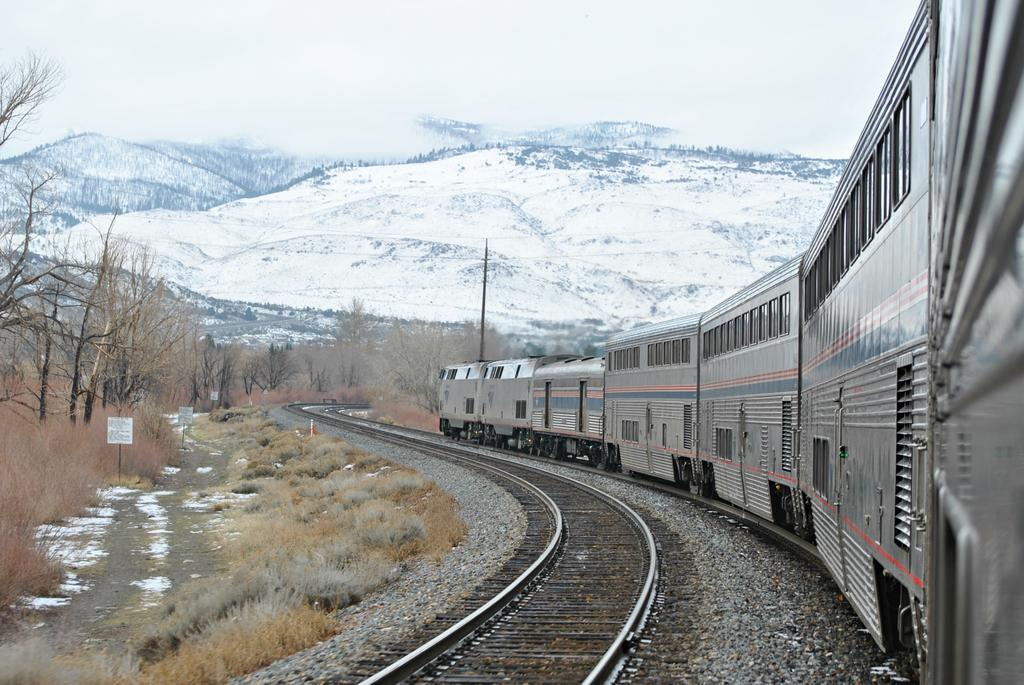What is the main subject of the image? The main subject of the image is a locomotive on the track. What is the condition of the track next to the locomotive? The track next to the locomotive is empty. What type of natural elements can be seen in the image? Stones, shrubs, trees, and mountains are visible in the image. What man-made structures are present in the image? Information boards are in the image. What part of the natural environment is visible in the image? The sky is visible in the image. What type of farm can be seen in the image? There is no farm present in the image. 